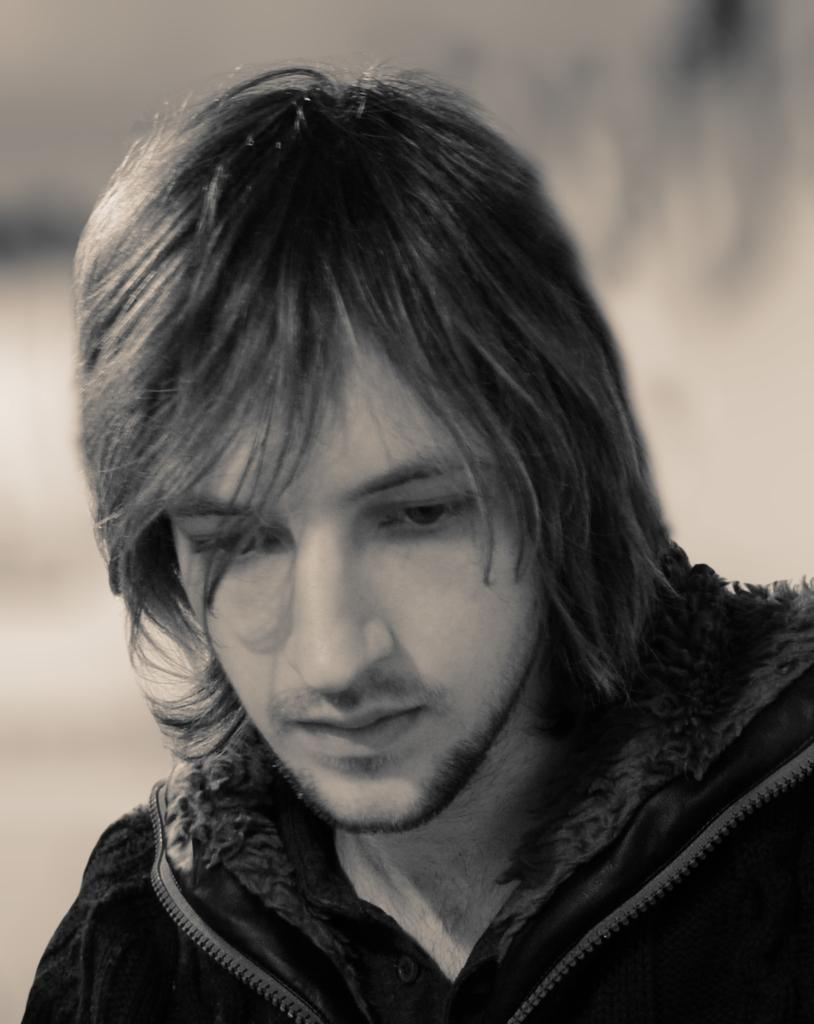Who is the main subject in the picture? There is a boy in the picture. What is the boy wearing? The boy is wearing a black jacket. Where is the boy positioned in the image? The boy is standing in the front. What is the boy doing in the image? The boy is looking down. How would you describe the background of the image? The background of the image is blurred. What type of quilt is being used to cover the family in the image? There is no family or quilt present in the image; it features a boy standing in the front and looking down. What sense is being evoked by the image? The image does not evoke a specific sense, as it is a still photograph. 